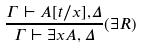Convert formula to latex. <formula><loc_0><loc_0><loc_500><loc_500>\frac { \Gamma \vdash A [ t / x ] , \Delta } { \Gamma \vdash \exists x A , \Delta } ( \exists R )</formula> 